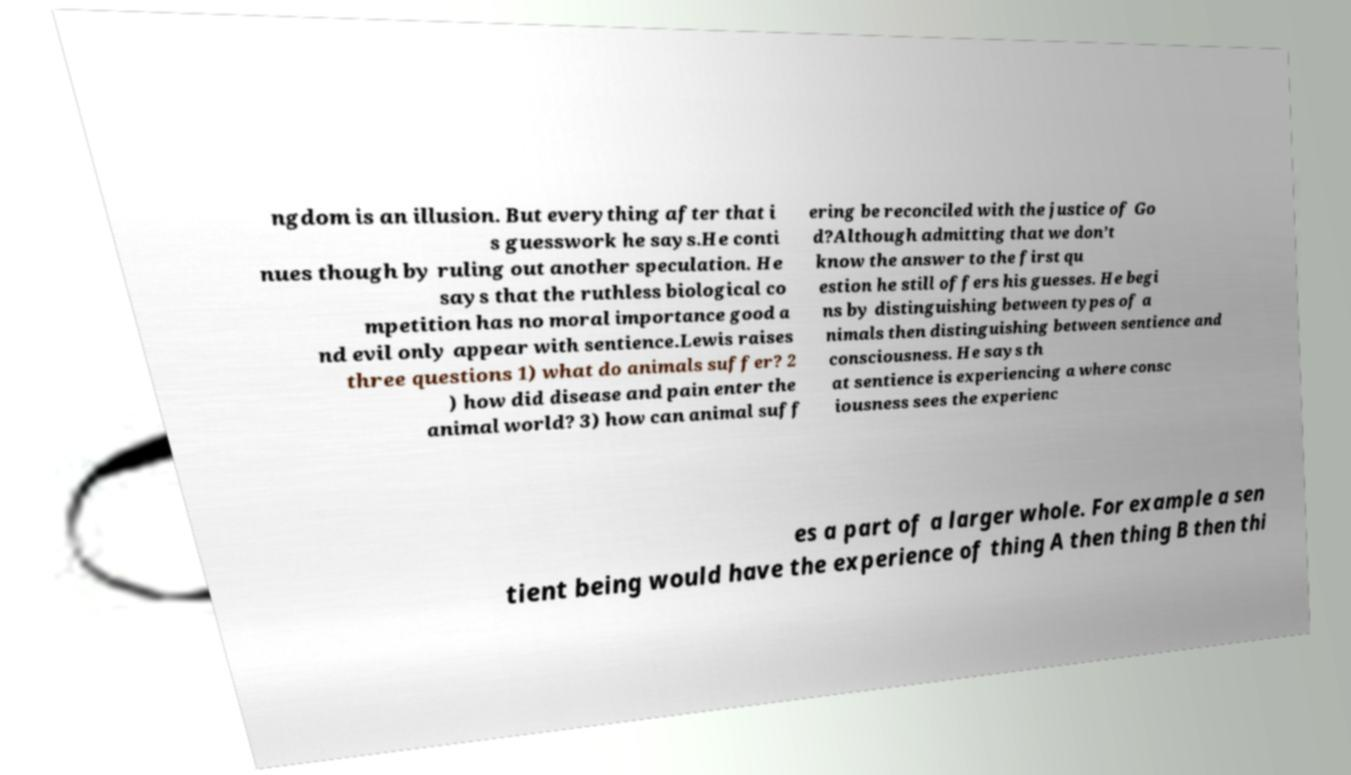There's text embedded in this image that I need extracted. Can you transcribe it verbatim? ngdom is an illusion. But everything after that i s guesswork he says.He conti nues though by ruling out another speculation. He says that the ruthless biological co mpetition has no moral importance good a nd evil only appear with sentience.Lewis raises three questions 1) what do animals suffer? 2 ) how did disease and pain enter the animal world? 3) how can animal suff ering be reconciled with the justice of Go d?Although admitting that we don’t know the answer to the first qu estion he still offers his guesses. He begi ns by distinguishing between types of a nimals then distinguishing between sentience and consciousness. He says th at sentience is experiencing a where consc iousness sees the experienc es a part of a larger whole. For example a sen tient being would have the experience of thing A then thing B then thi 